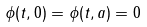<formula> <loc_0><loc_0><loc_500><loc_500>\phi ( t , 0 ) = \phi ( t , a ) = 0</formula> 